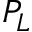<formula> <loc_0><loc_0><loc_500><loc_500>P _ { L }</formula> 